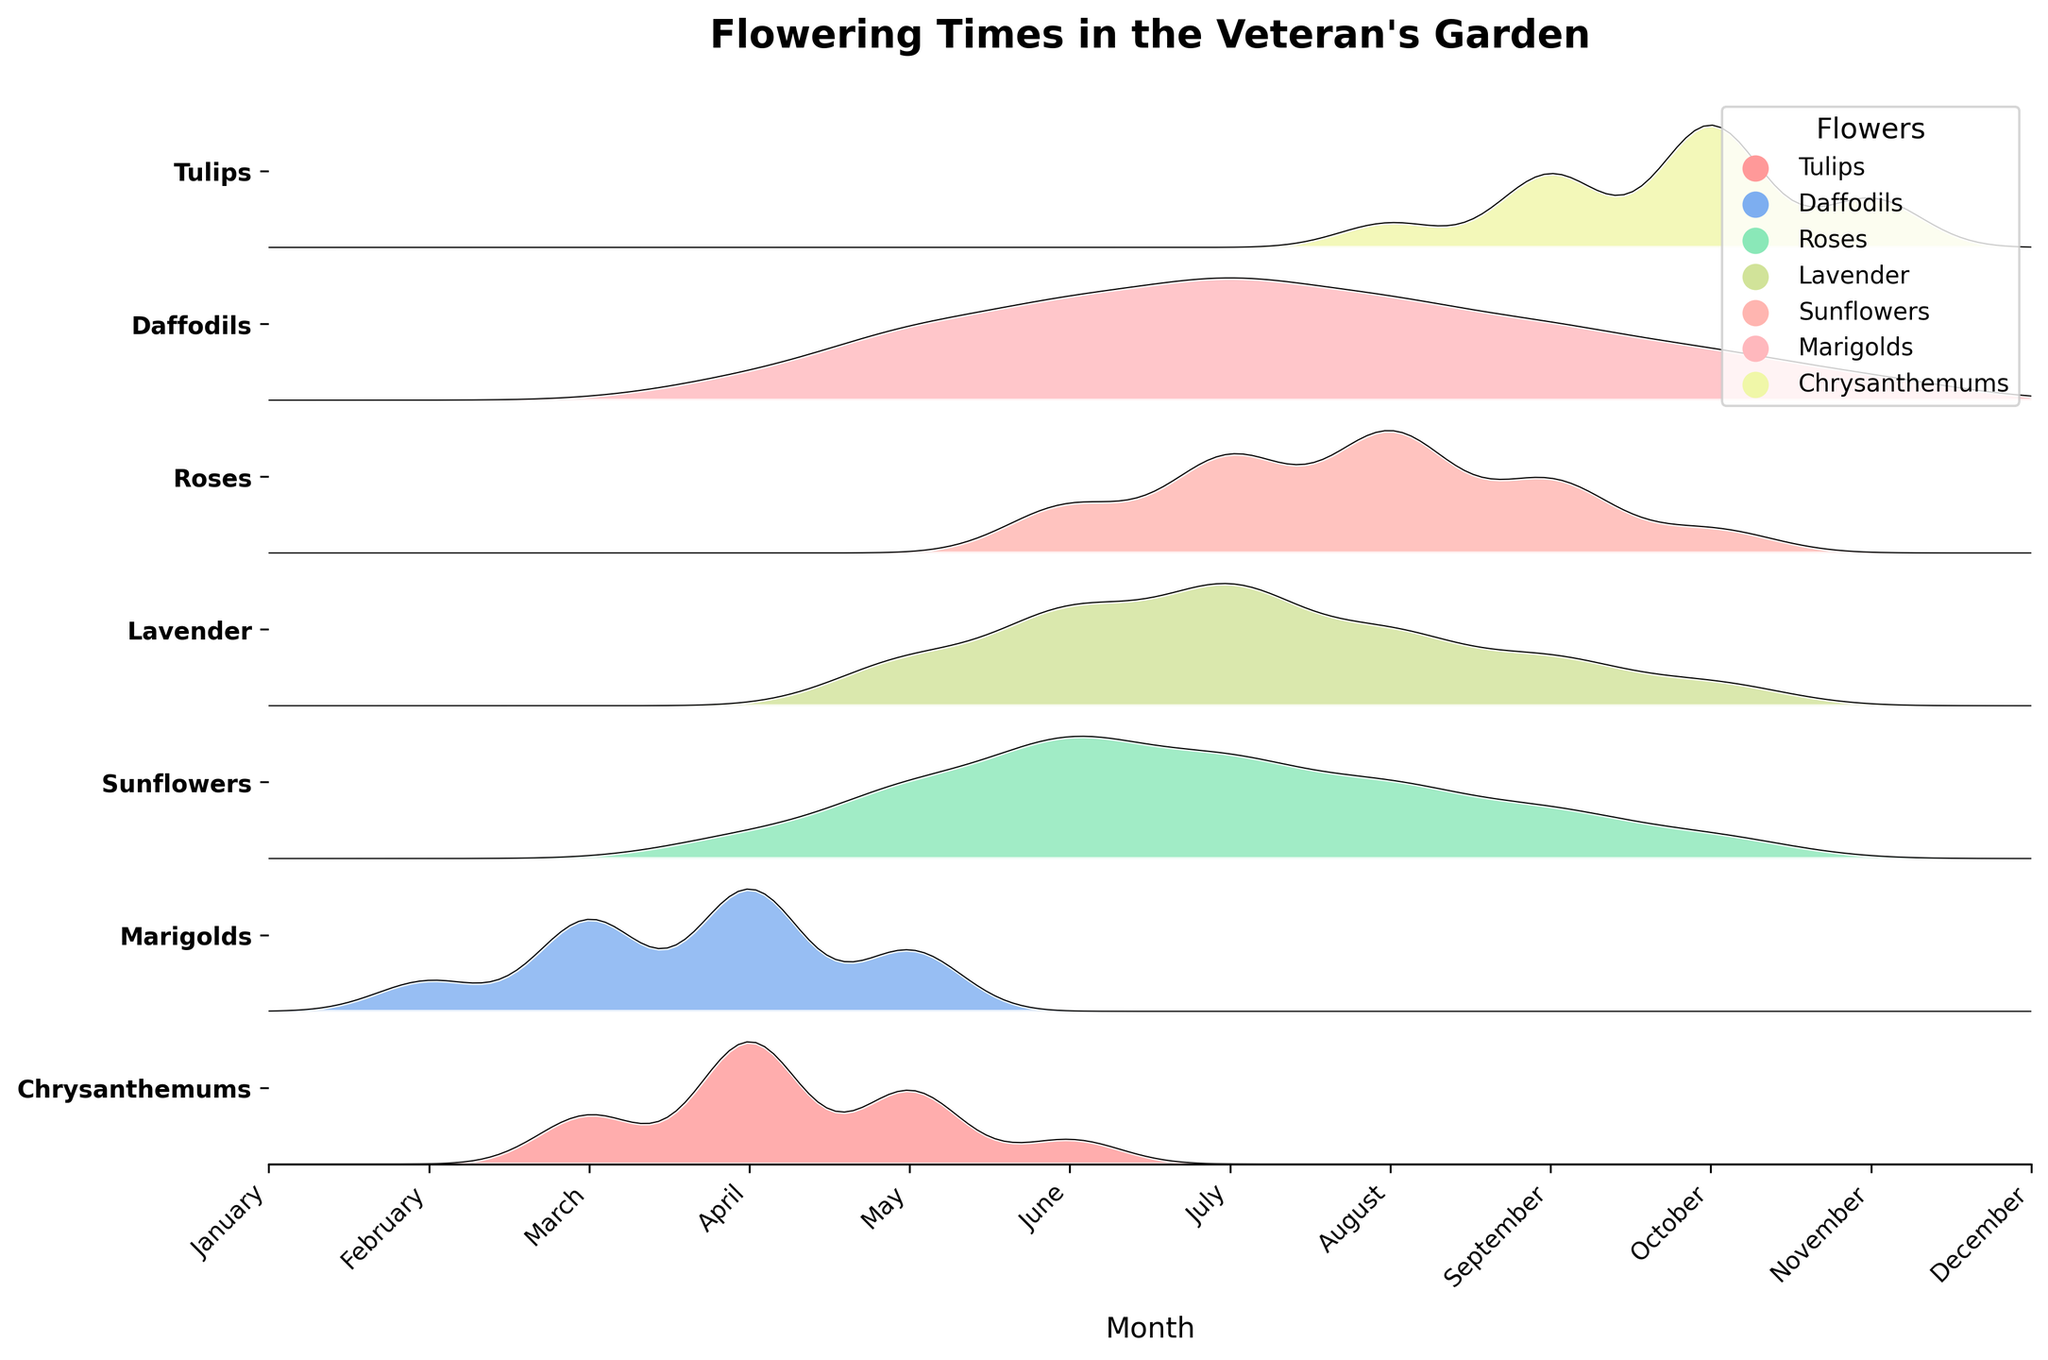What is the title of the plot? The title of the plot is usually located at the top center of the figure.
Answer: Flowering Times in the Veteran's Garden Which flower starts blooming the earliest in the year? Tulips start blooming in March, which is the earliest compared to other flowers.
Answer: Tulips During which month do all flowers except Tulips show no flowering activity? By examining the months on the x-axis, we can see that in February, all flowers except Daffodils have zero values, indicating they don't bloom.
Answer: February How many flowers bloom in July? By looking at the y-axis, we can count the number of filled ridgelines at July's position.
Answer: 6 Which flower has the highest flowering density in June? By observing the peaks of the ridgelines, Roses show the highest density in June.
Answer: Roses When comparing Tulips and Daffodils, which flower has a longer blooming period? Tulips bloom from March to June (4 months), while Daffodils bloom from February to May (4 months). Hence, both have the same duration.
Answer: Both have the same duration Describe the blooming pattern of Sunflowers throughout the year. By tracing the ridgeline for Sunflowers, they start blooming in June, peak in August, and gradually decline until October.
Answer: June to October, peak in August What is the maximum number of flowers blooming in a single month, and which month is it? Looking at the height of all the ridgelines for each month, the highest occurrence is in July where 6 different flowers bloom.
Answer: 6, July Between Lavender and Marigolds, which one blooms earlier and longer? Lavender starts in May and ends in October (6 months), while Marigolds start in April and also end in October (7 months), indicating Marigolds bloom earlier and for a longer duration.
Answer: Marigolds Which flower has a consistent but prolonged flowering pattern? Chrysanthemums show a consistent flowering pattern starting from August to November and occasionally in October.
Answer: Chrysanthemums 